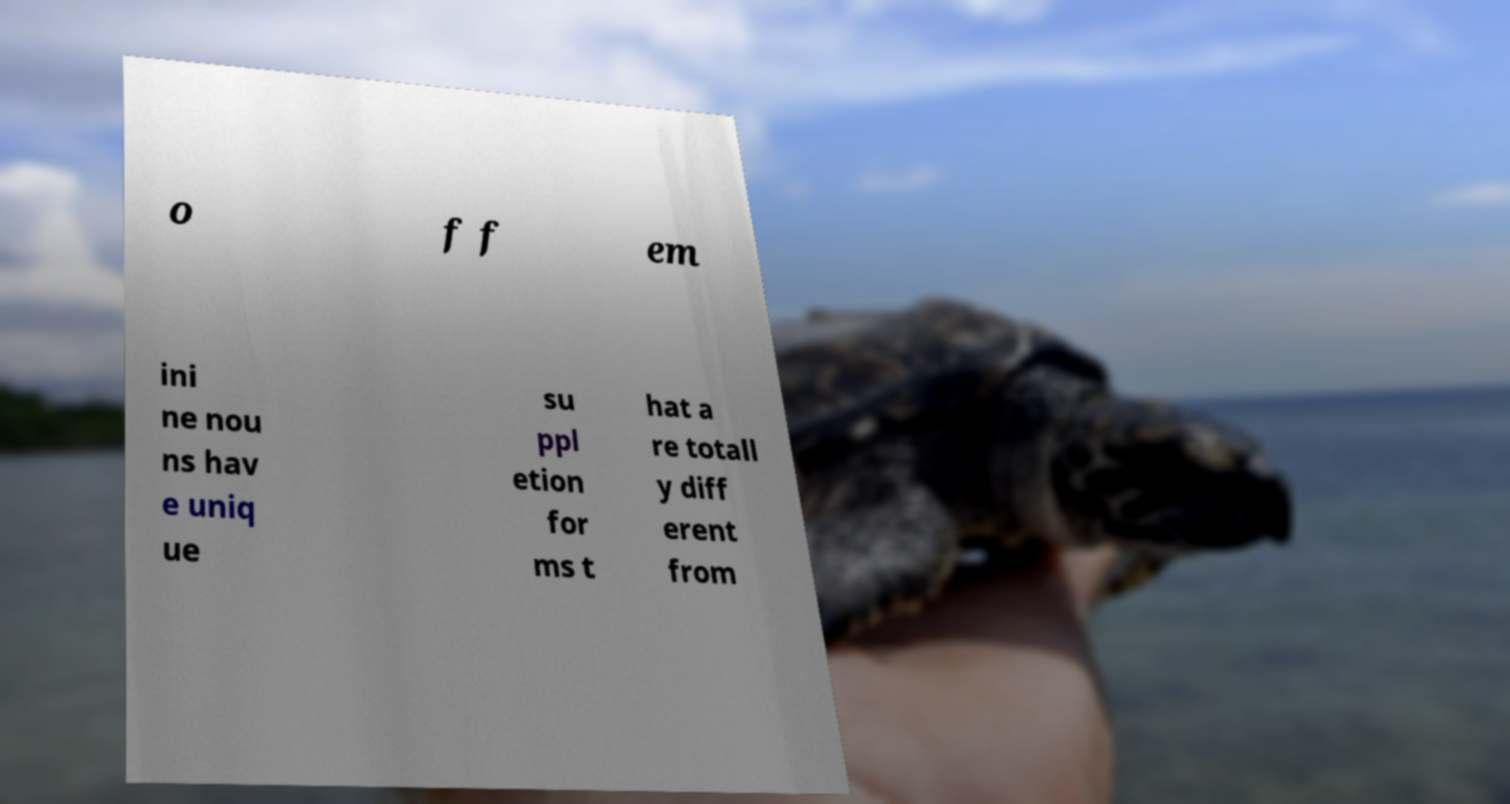Please identify and transcribe the text found in this image. o f f em ini ne nou ns hav e uniq ue su ppl etion for ms t hat a re totall y diff erent from 